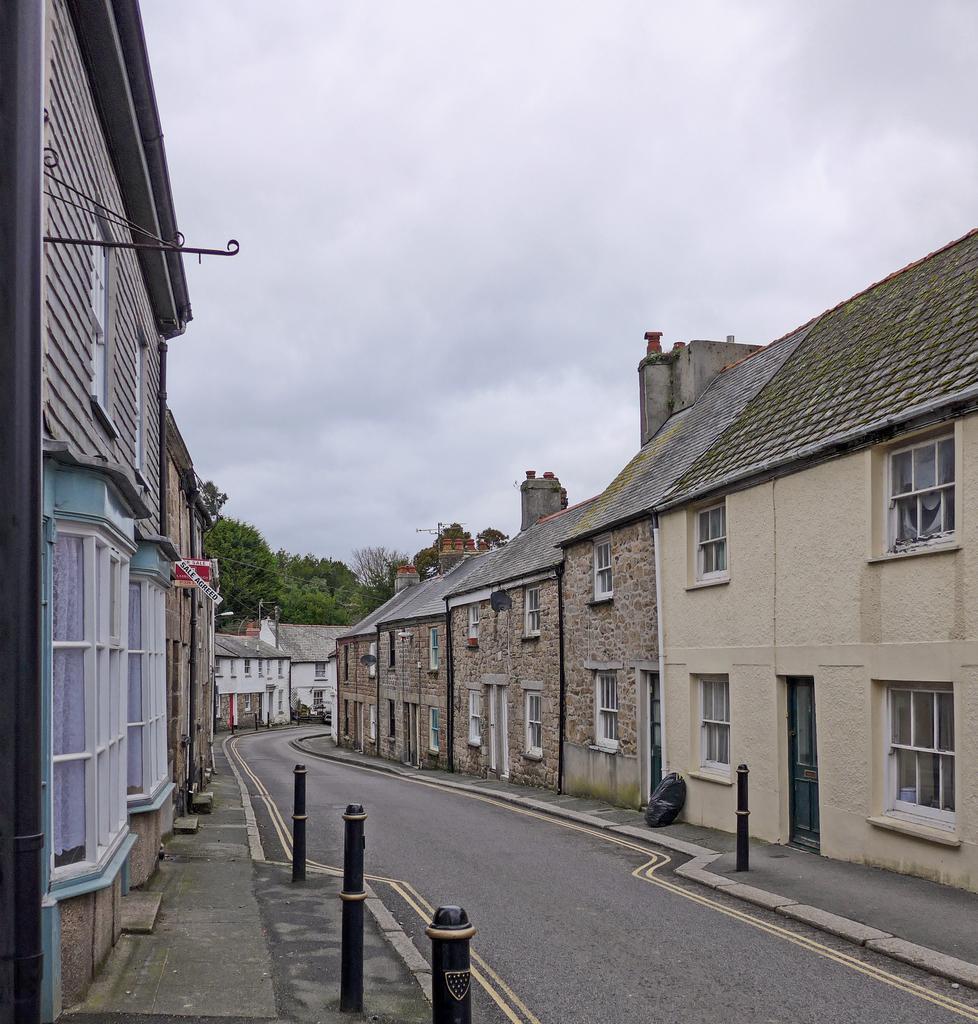Can you describe this image briefly? In this image I can see few buildings, they are in brown, cream color. I can also see few poles in black color, trees in green color, sky in white color. 